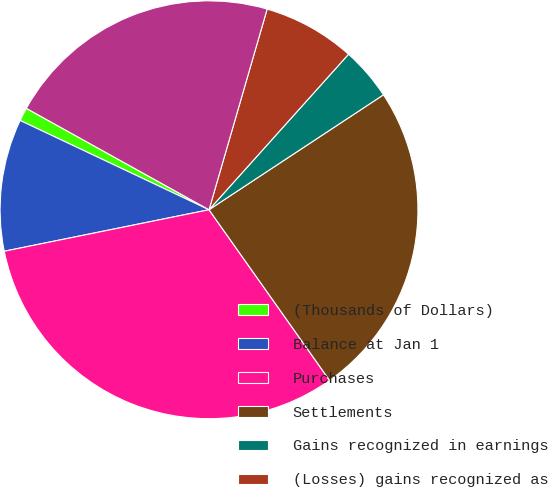Convert chart to OTSL. <chart><loc_0><loc_0><loc_500><loc_500><pie_chart><fcel>(Thousands of Dollars)<fcel>Balance at Jan 1<fcel>Purchases<fcel>Settlements<fcel>Gains recognized in earnings<fcel>(Losses) gains recognized as<fcel>Balance at Dec 31<nl><fcel>1.04%<fcel>10.21%<fcel>31.61%<fcel>24.48%<fcel>4.09%<fcel>7.15%<fcel>21.42%<nl></chart> 